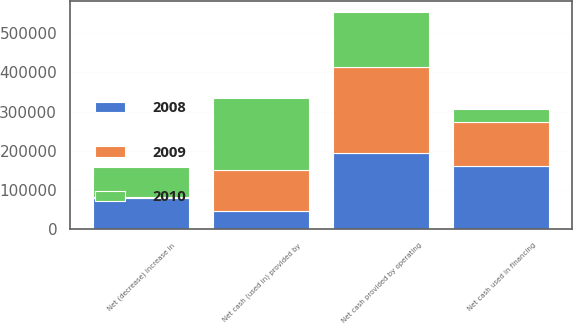Convert chart. <chart><loc_0><loc_0><loc_500><loc_500><stacked_bar_chart><ecel><fcel>Net cash provided by operating<fcel>Net cash (used in) provided by<fcel>Net cash used in financing<fcel>Net (decrease) increase in<nl><fcel>2010<fcel>141208<fcel>183997<fcel>34228<fcel>77017<nl><fcel>2008<fcel>193862<fcel>45729<fcel>161647<fcel>77944<nl><fcel>2009<fcel>219169<fcel>105775<fcel>110529<fcel>2865<nl></chart> 